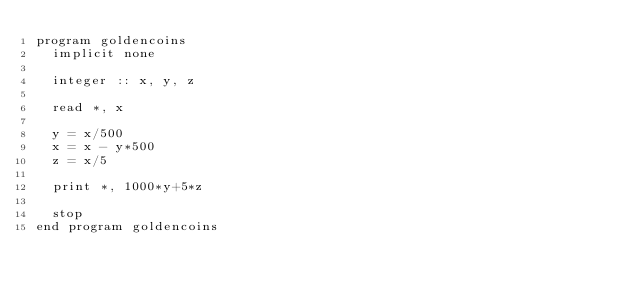Convert code to text. <code><loc_0><loc_0><loc_500><loc_500><_FORTRAN_>program goldencoins
  implicit none

  integer :: x, y, z

  read *, x

  y = x/500
  x = x - y*500
  z = x/5

  print *, 1000*y+5*z

  stop
end program goldencoins
</code> 